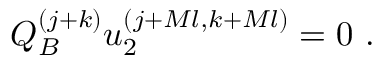Convert formula to latex. <formula><loc_0><loc_0><loc_500><loc_500>Q _ { B } ^ { ( j + k ) } u _ { 2 } ^ { ( j + M l , k + M l ) } = 0 \, .</formula> 